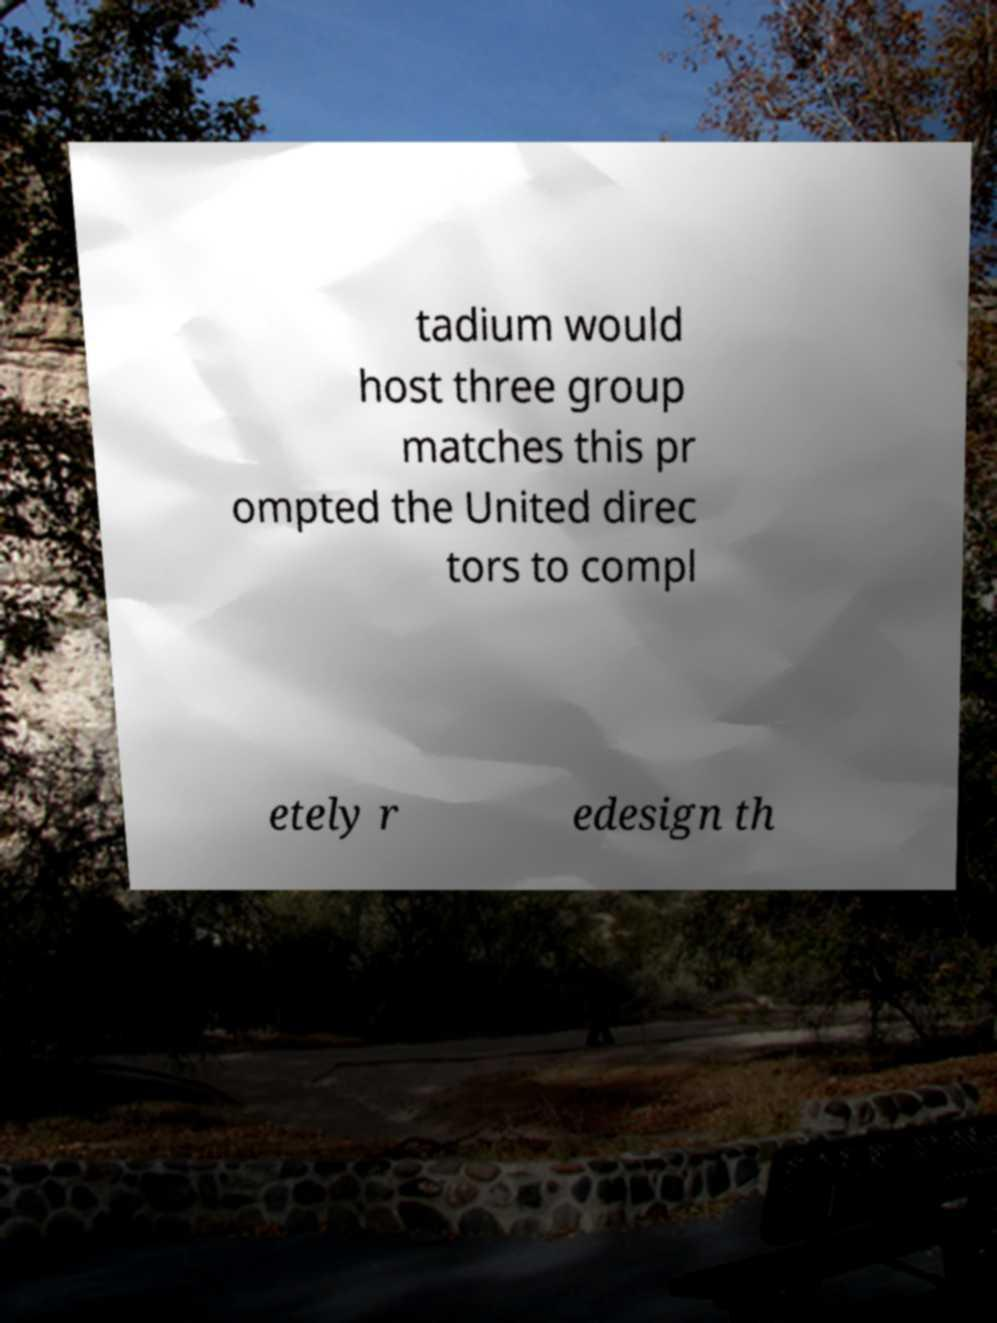Please read and relay the text visible in this image. What does it say? tadium would host three group matches this pr ompted the United direc tors to compl etely r edesign th 